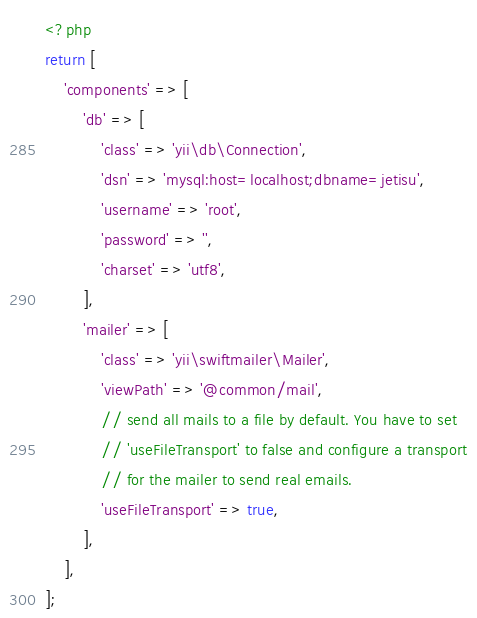Convert code to text. <code><loc_0><loc_0><loc_500><loc_500><_PHP_><?php
return [
    'components' => [
        'db' => [
            'class' => 'yii\db\Connection',
            'dsn' => 'mysql:host=localhost;dbname=jetisu',
            'username' => 'root',
            'password' => '',
            'charset' => 'utf8',
        ],
        'mailer' => [
            'class' => 'yii\swiftmailer\Mailer',
            'viewPath' => '@common/mail',
            // send all mails to a file by default. You have to set
            // 'useFileTransport' to false and configure a transport
            // for the mailer to send real emails.
            'useFileTransport' => true,
        ],
    ],
];
</code> 